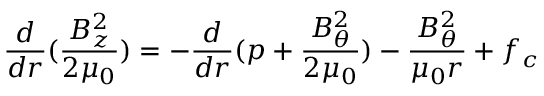<formula> <loc_0><loc_0><loc_500><loc_500>\frac { d } { d r } ( \frac { B _ { z } ^ { 2 } } { 2 \mu _ { 0 } } ) = - \frac { d } { d r } ( p + \frac { B _ { \theta } ^ { 2 } } { 2 \mu _ { 0 } } ) - \frac { B _ { \theta } ^ { 2 } } { \mu _ { 0 } r } + f _ { c }</formula> 